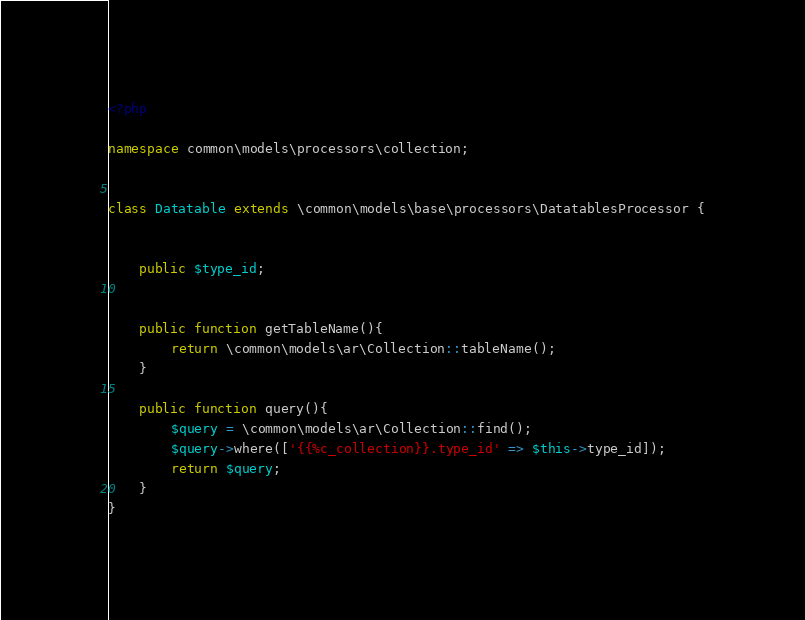Convert code to text. <code><loc_0><loc_0><loc_500><loc_500><_PHP_><?php

namespace common\models\processors\collection;


class Datatable extends \common\models\base\processors\DatatablesProcessor {


    public $type_id;


	public function getTableName(){
		return \common\models\ar\Collection::tableName();
	}

    public function query(){
        $query = \common\models\ar\Collection::find();
        $query->where(['{{%c_collection}}.type_id' => $this->type_id]);
        return $query;
    }
}</code> 